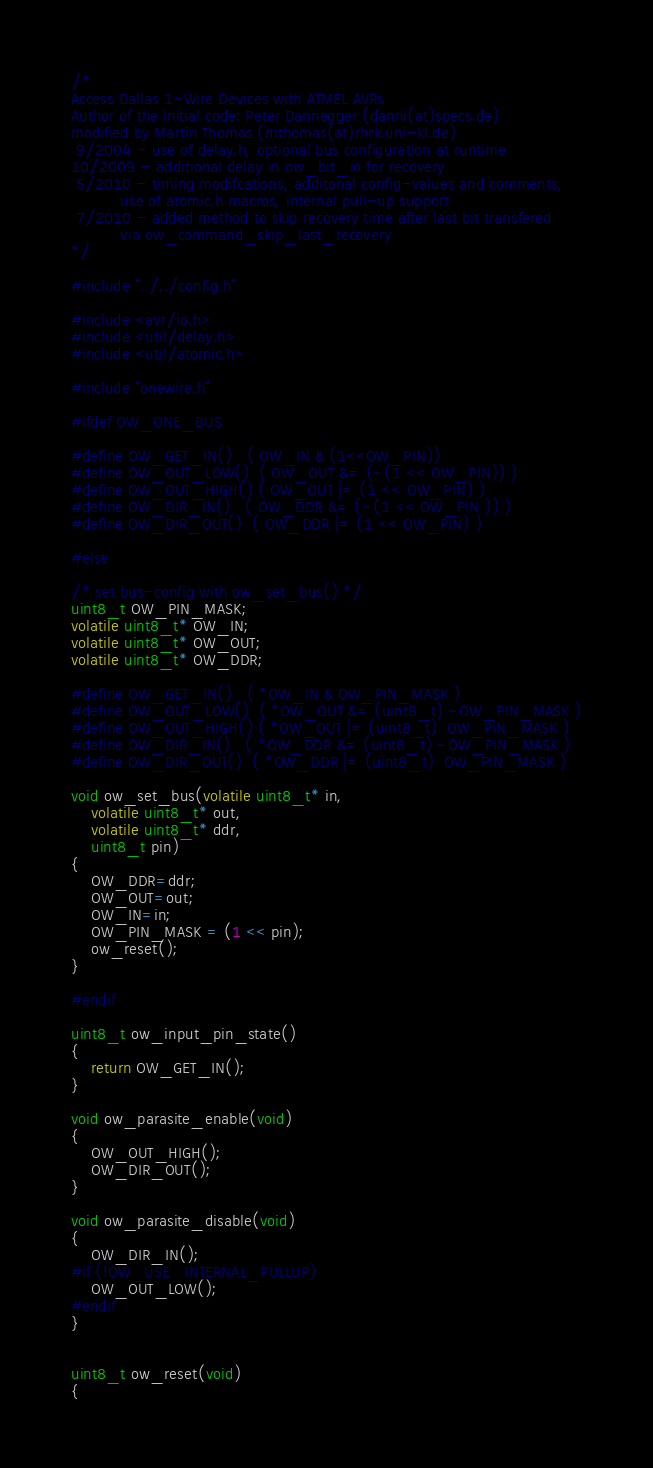<code> <loc_0><loc_0><loc_500><loc_500><_C_>/* 
Access Dallas 1-Wire Devices with ATMEL AVRs
Author of the initial code: Peter Dannegger (danni(at)specs.de)
modified by Martin Thomas (mthomas(at)rhrk.uni-kl.de)
 9/2004 - use of delay.h, optional bus configuration at runtime
10/2009 - additional delay in ow_bit_io for recovery
 5/2010 - timing modifcations, additonal config-values and comments,
          use of atomic.h macros, internal pull-up support
 7/2010 - added method to skip recovery time after last bit transfered
          via ow_command_skip_last_recovery
*/

#include "../../config.h"

#include <avr/io.h>
#include <util/delay.h>
#include <util/atomic.h>

#include "onewire.h"

#ifdef OW_ONE_BUS

#define OW_GET_IN()   ( OW_IN & (1<<OW_PIN))
#define OW_OUT_LOW()  ( OW_OUT &= (~(1 << OW_PIN)) )
#define OW_OUT_HIGH() ( OW_OUT |= (1 << OW_PIN) )
#define OW_DIR_IN()   ( OW_DDR &= (~(1 << OW_PIN )) )
#define OW_DIR_OUT()  ( OW_DDR |= (1 << OW_PIN) )

#else

/* set bus-config with ow_set_bus() */
uint8_t OW_PIN_MASK; 
volatile uint8_t* OW_IN;
volatile uint8_t* OW_OUT;
volatile uint8_t* OW_DDR;

#define OW_GET_IN()   ( *OW_IN & OW_PIN_MASK )
#define OW_OUT_LOW()  ( *OW_OUT &= (uint8_t) ~OW_PIN_MASK )
#define OW_OUT_HIGH() ( *OW_OUT |= (uint8_t)  OW_PIN_MASK )
#define OW_DIR_IN()   ( *OW_DDR &= (uint8_t) ~OW_PIN_MASK )
#define OW_DIR_OUT()  ( *OW_DDR |= (uint8_t)  OW_PIN_MASK )

void ow_set_bus(volatile uint8_t* in,
	volatile uint8_t* out,
	volatile uint8_t* ddr,
	uint8_t pin)
{
	OW_DDR=ddr;
	OW_OUT=out;
	OW_IN=in;
	OW_PIN_MASK = (1 << pin);
	ow_reset();
}

#endif

uint8_t ow_input_pin_state()
{
	return OW_GET_IN();
}

void ow_parasite_enable(void)
{
	OW_OUT_HIGH();
	OW_DIR_OUT();
}

void ow_parasite_disable(void)
{
	OW_DIR_IN();
#if (!OW_USE_INTERNAL_PULLUP)
	OW_OUT_LOW();
#endif
}


uint8_t ow_reset(void)
{</code> 